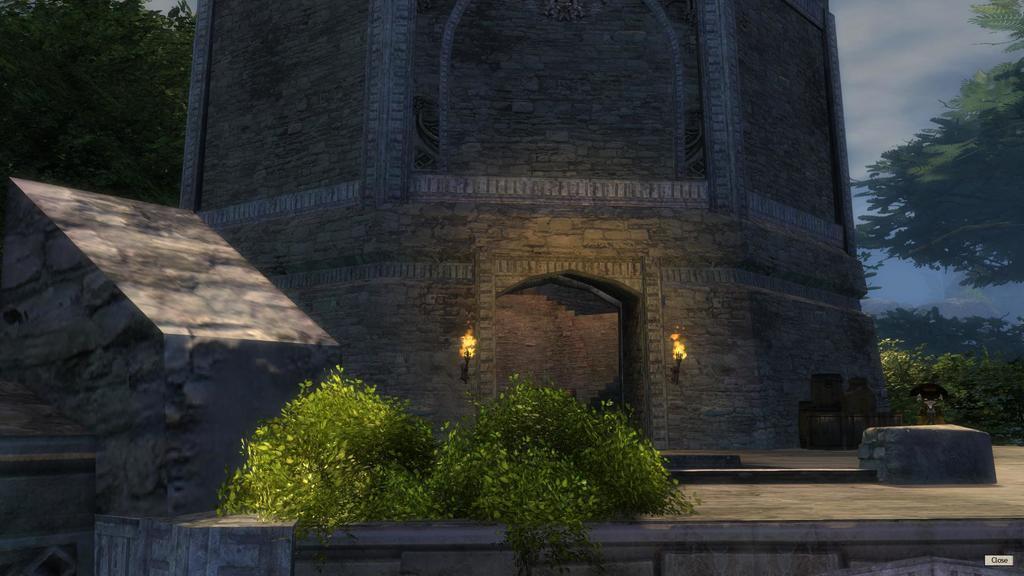How would you summarize this image in a sentence or two? This is an animated picture. In the foreground of the picture there are plants. In the center of the picture there is a castle. On the right there are trees and boxes. On the left there are trees. 